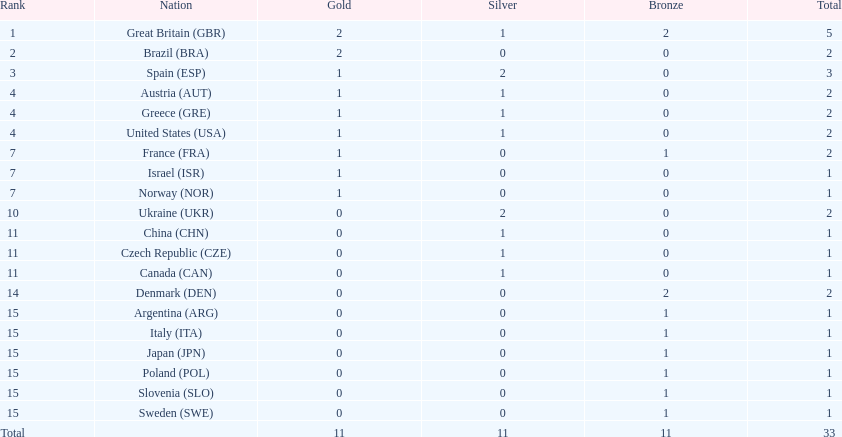How many countries won at least 2 medals in sailing? 9. 